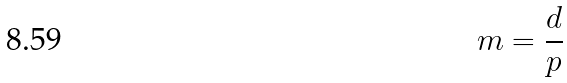Convert formula to latex. <formula><loc_0><loc_0><loc_500><loc_500>m = \frac { d } { p }</formula> 